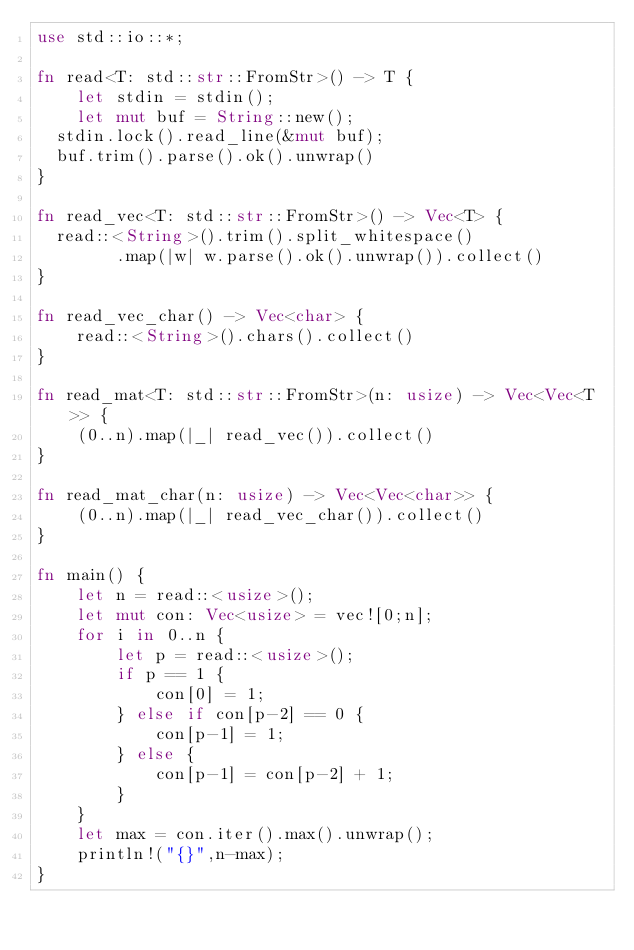<code> <loc_0><loc_0><loc_500><loc_500><_Rust_>use std::io::*;

fn read<T: std::str::FromStr>() -> T {
    let stdin = stdin();
    let mut buf = String::new();
	stdin.lock().read_line(&mut buf);
	buf.trim().parse().ok().unwrap()
}

fn read_vec<T: std::str::FromStr>() -> Vec<T> {
	read::<String>().trim().split_whitespace()
        .map(|w| w.parse().ok().unwrap()).collect()
}

fn read_vec_char() -> Vec<char> {
    read::<String>().chars().collect()
}

fn read_mat<T: std::str::FromStr>(n: usize) -> Vec<Vec<T>> {
    (0..n).map(|_| read_vec()).collect()
}

fn read_mat_char(n: usize) -> Vec<Vec<char>> {
    (0..n).map(|_| read_vec_char()).collect()
}

fn main() {
    let n = read::<usize>();
    let mut con: Vec<usize> = vec![0;n];
    for i in 0..n {
        let p = read::<usize>();
        if p == 1 {
            con[0] = 1;
        } else if con[p-2] == 0 {
            con[p-1] = 1;
        } else {
            con[p-1] = con[p-2] + 1;
        }
    }
    let max = con.iter().max().unwrap();
    println!("{}",n-max);
}
</code> 